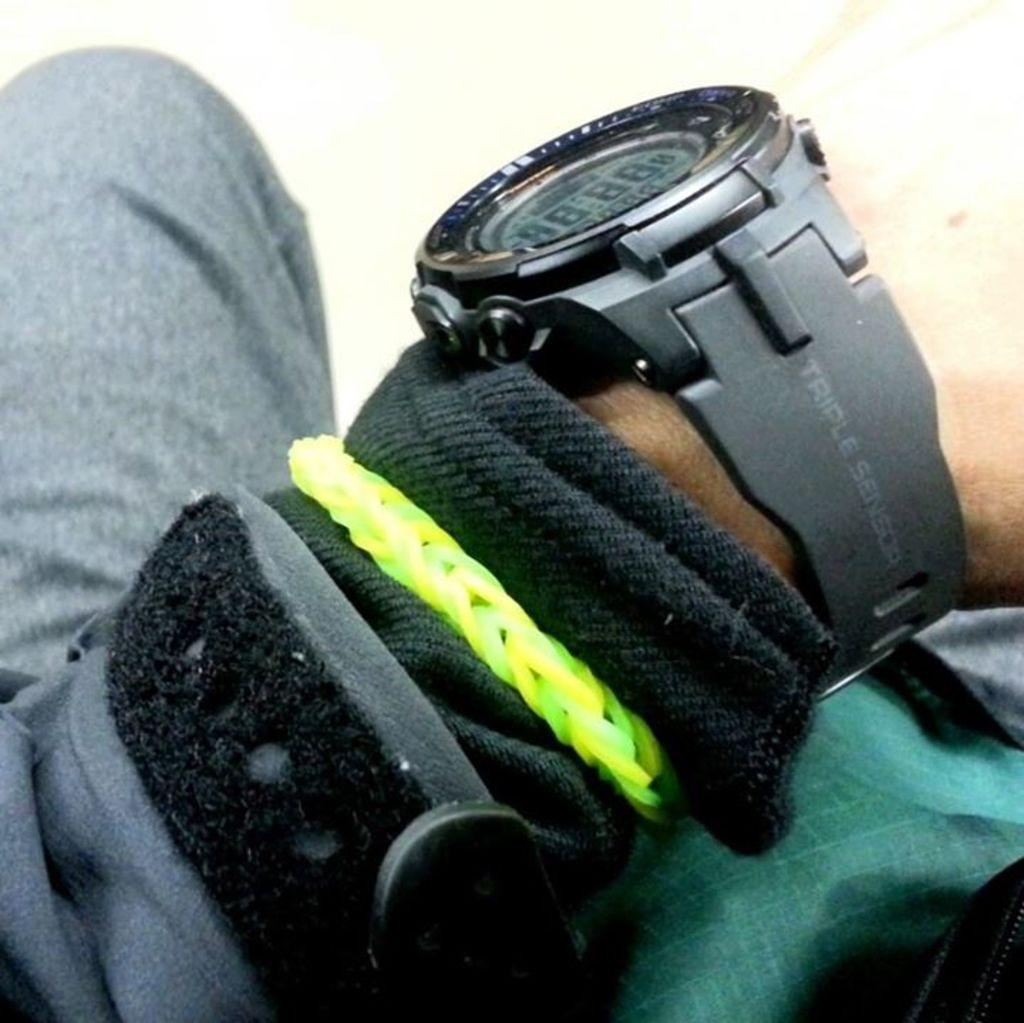Provide a one-sentence caption for the provided image. the numbers 8 repeating on a watch someone has. 